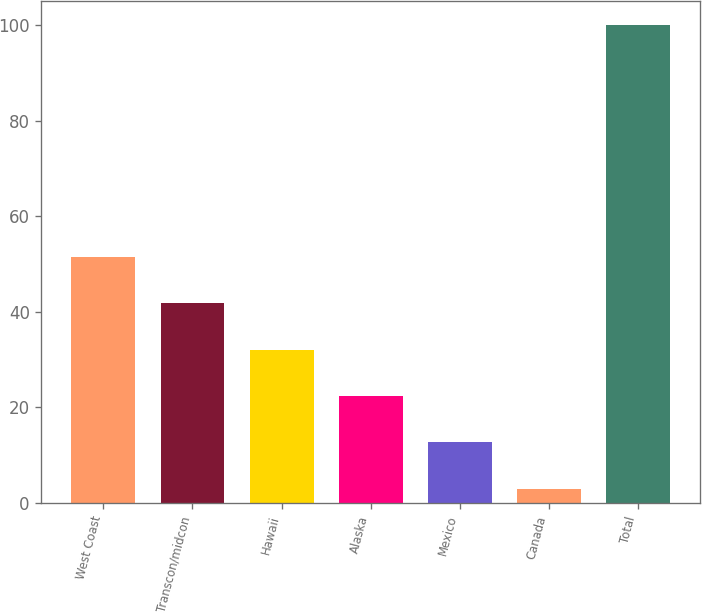<chart> <loc_0><loc_0><loc_500><loc_500><bar_chart><fcel>West Coast<fcel>Transcon/midcon<fcel>Hawaii<fcel>Alaska<fcel>Mexico<fcel>Canada<fcel>Total<nl><fcel>51.5<fcel>41.8<fcel>32.1<fcel>22.4<fcel>12.7<fcel>3<fcel>100<nl></chart> 